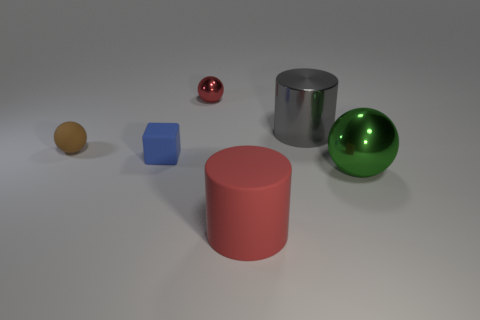Add 2 big metal spheres. How many objects exist? 8 Subtract all cubes. How many objects are left? 5 Subtract all red cylinders. Subtract all blue matte blocks. How many objects are left? 4 Add 1 big green spheres. How many big green spheres are left? 2 Add 2 small rubber blocks. How many small rubber blocks exist? 3 Subtract 0 green cylinders. How many objects are left? 6 